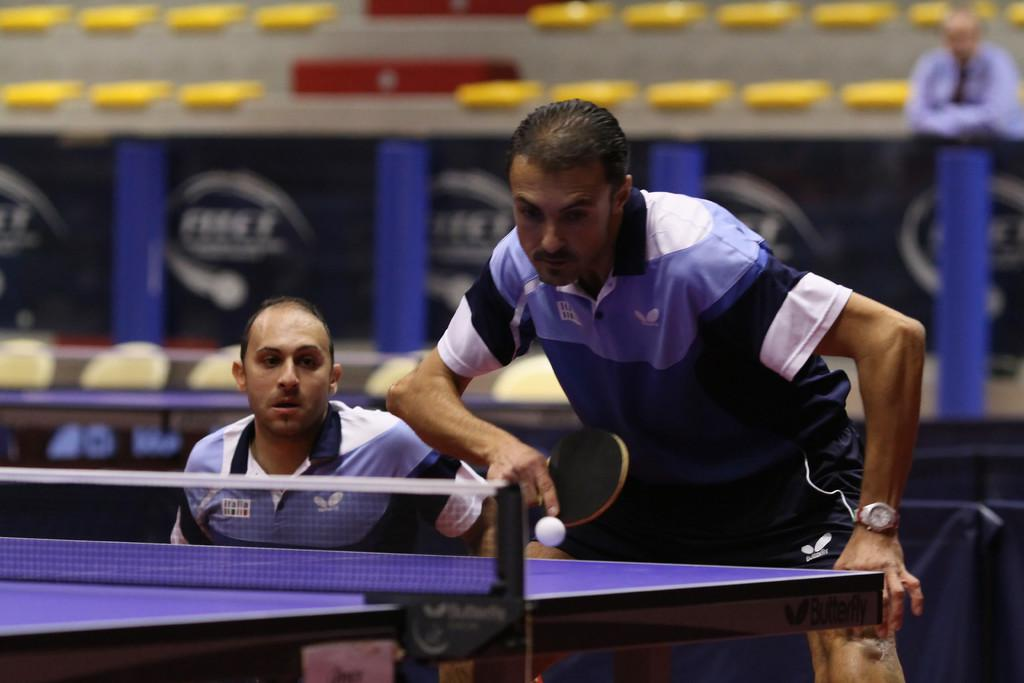How many people are in the image? There are two people in the image. Where are the two people located in the image? The two people are at the right side of the image. What activity are the two people engaged in? The two people are playing a table tennis game. What equipment is necessary for their activity? There is a table tennis board in the image. What type of pen is the person using to play table tennis in the image? There is no pen present in the image; the two people are playing table tennis using a table tennis paddle. What hobbies does the person on the left side of the image have, besides playing table tennis? The image only shows the two people playing table tennis, so we cannot determine any other hobbies they might have. 